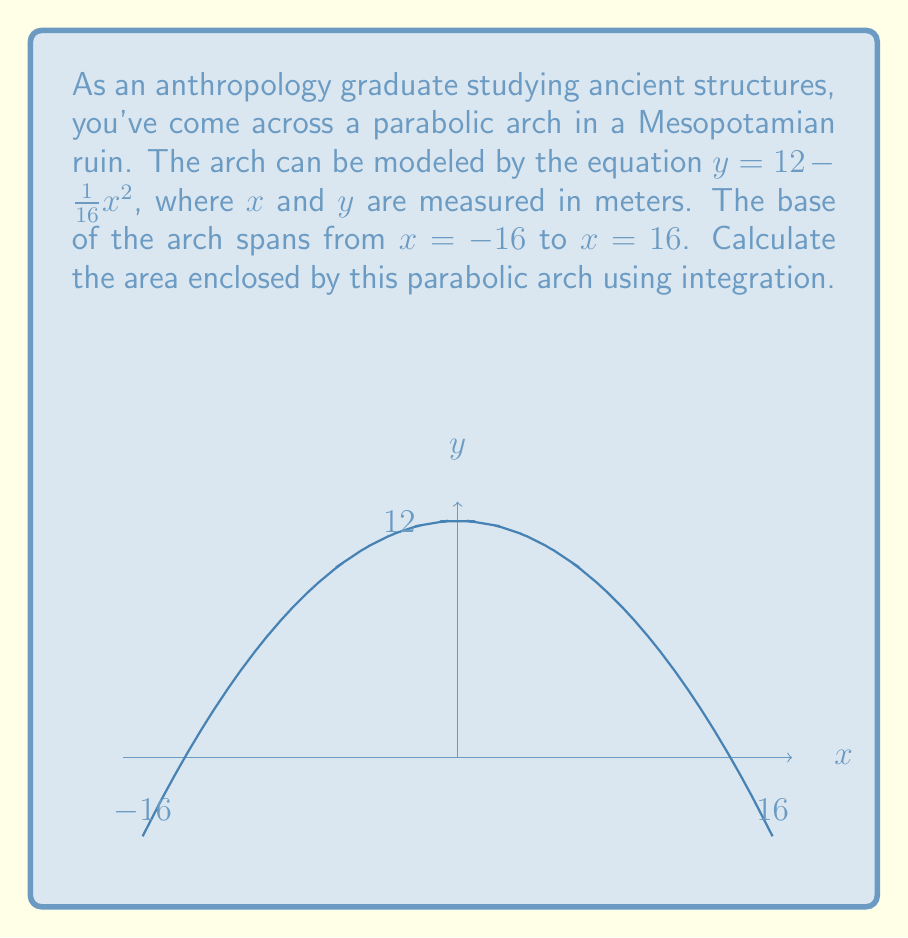Teach me how to tackle this problem. To calculate the area enclosed by the parabolic arch, we need to integrate the function from $x = -16$ to $x = 16$. Here's the step-by-step process:

1) The area is given by the definite integral:

   $$A = \int_{-16}^{16} (12 - \frac{1}{16}x^2) dx$$

2) Let's integrate this function:
   
   $$A = [12x - \frac{1}{48}x^3]_{-16}^{16}$$

3) Now, let's evaluate the integral at the limits:

   $$A = (12(16) - \frac{1}{48}(16)^3) - (12(-16) - \frac{1}{48}(-16)^3)$$

4) Simplify:
   
   $$A = (192 - \frac{4096}{48}) - (-192 - \frac{-4096}{48})$$
   
   $$A = (192 - \frac{4096}{48}) - (-192 + \frac{4096}{48})$$

5) Combine like terms:
   
   $$A = 192 - \frac{4096}{48} + 192 + \frac{4096}{48} = 384$$

Therefore, the area enclosed by the parabolic arch is 384 square meters.
Answer: $384$ m² 